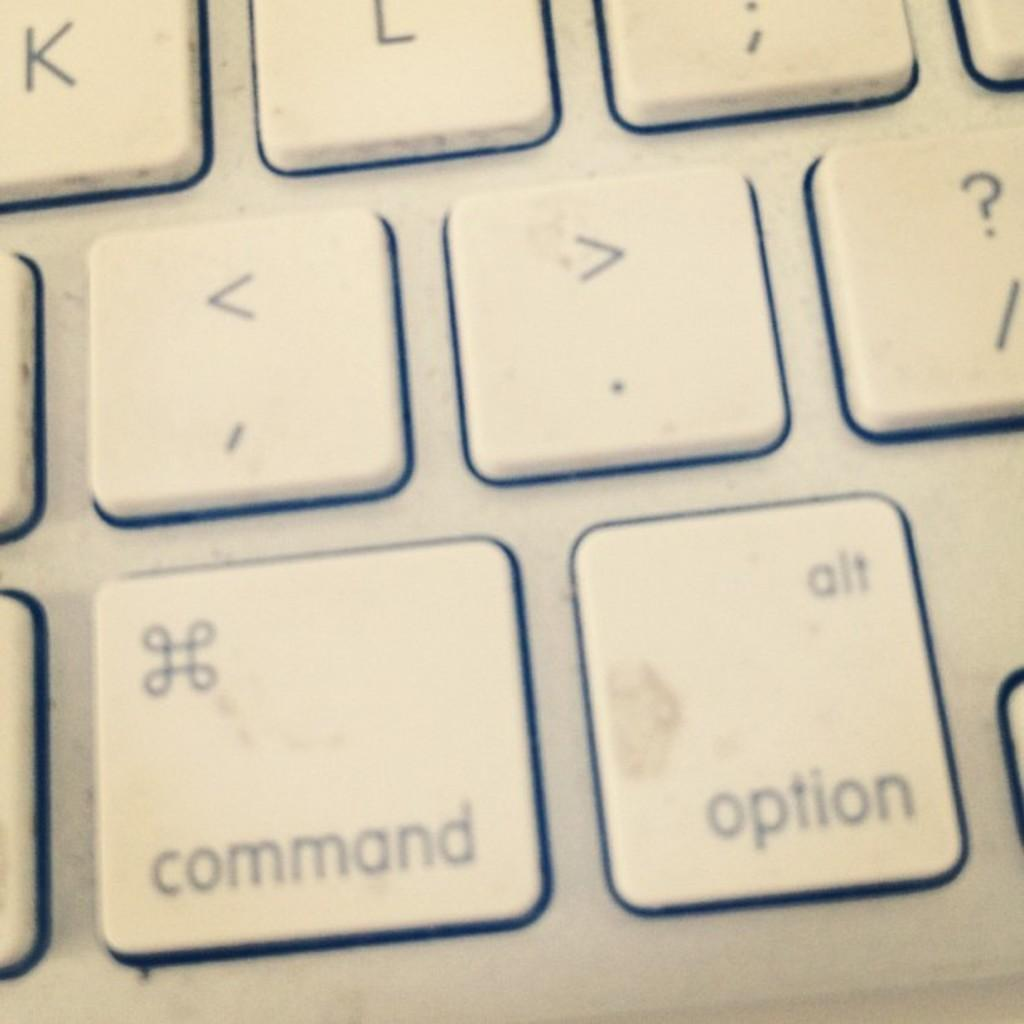<image>
Present a compact description of the photo's key features. Mac computer keyboard section featuring command, option, <, >, ?, K, L, ; keys. 